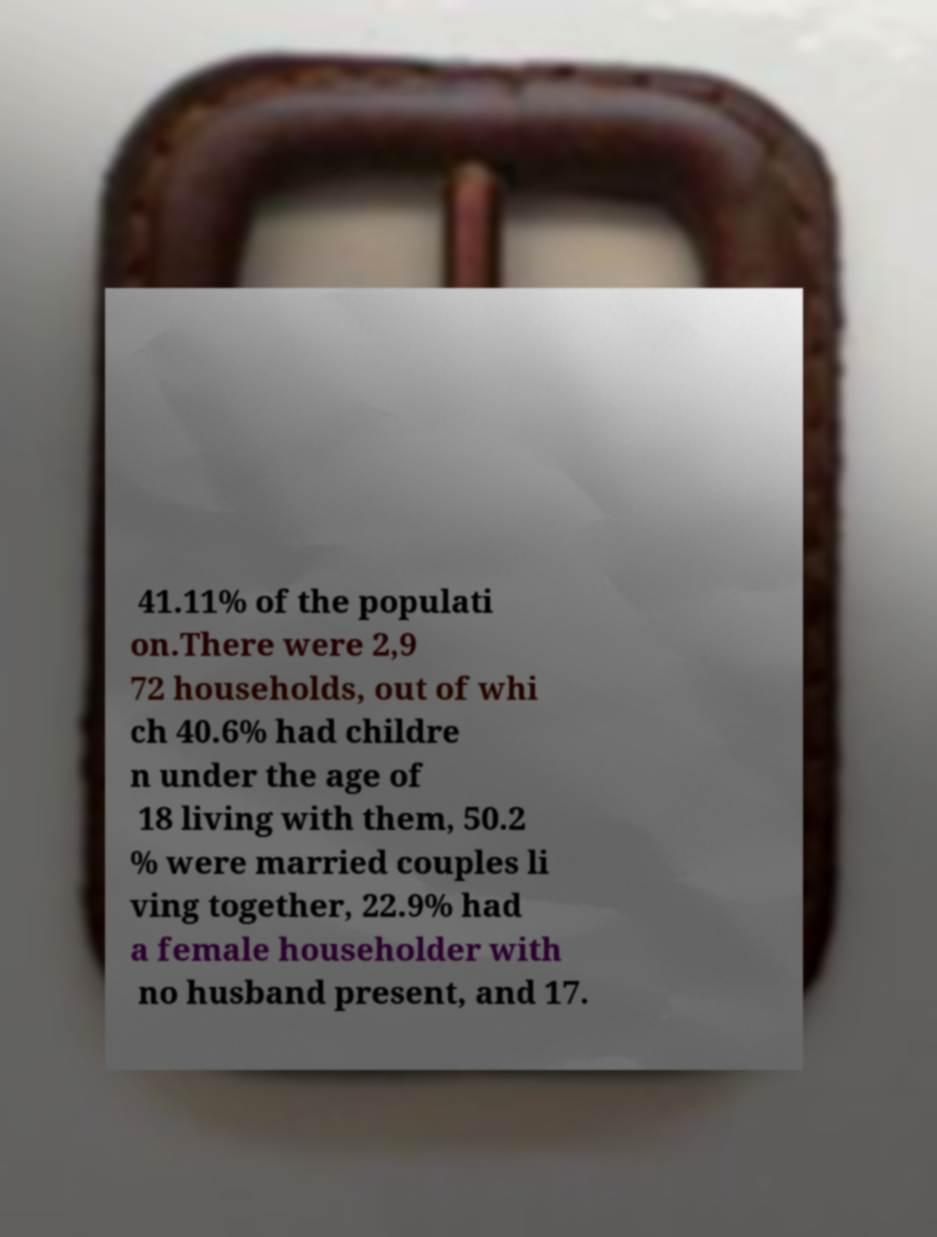Please identify and transcribe the text found in this image. 41.11% of the populati on.There were 2,9 72 households, out of whi ch 40.6% had childre n under the age of 18 living with them, 50.2 % were married couples li ving together, 22.9% had a female householder with no husband present, and 17. 